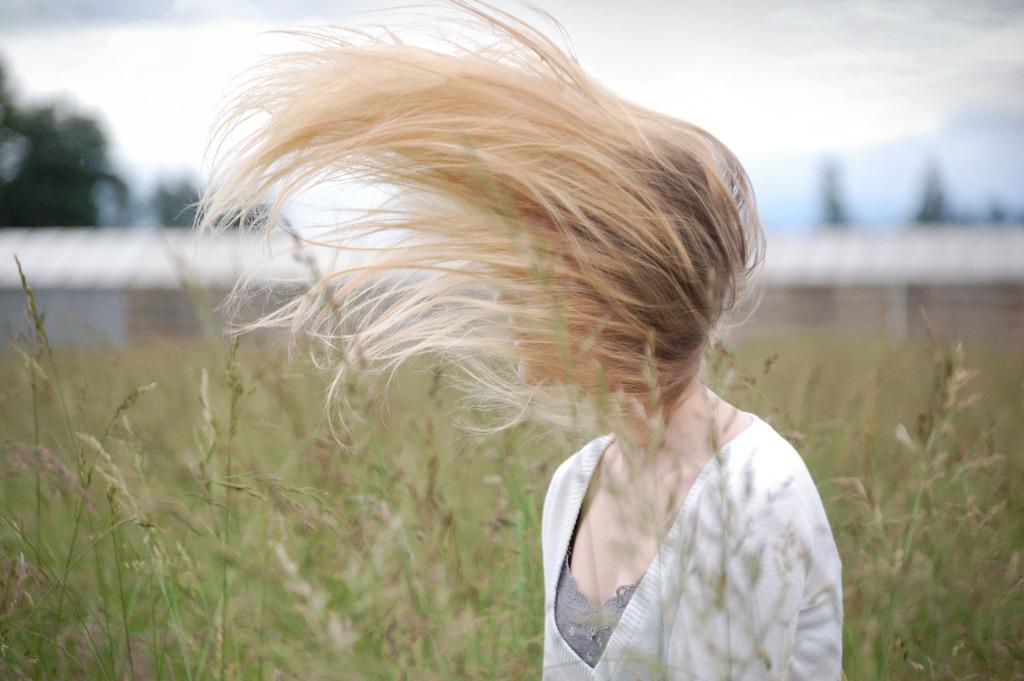How would you summarize this image in a sentence or two? In the image there is a girl in blond hair standing in the middle and behind there are plants and above its sky with clouds. 